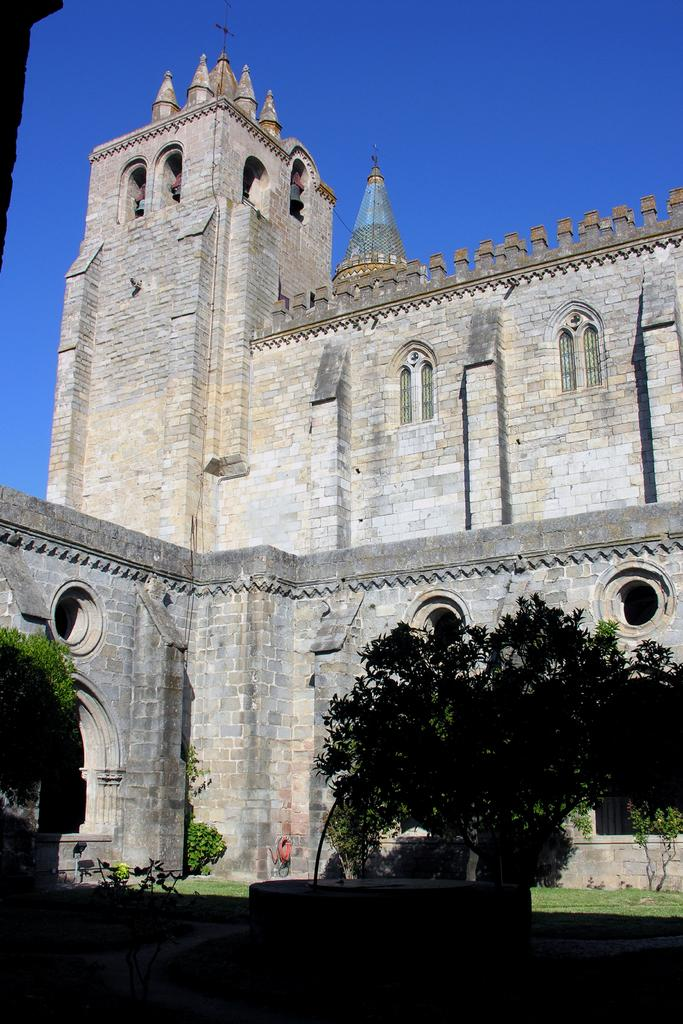What type of plant can be seen in the image? There is a tree in the image. What type of structure is present in the image? There is an old house in the image. What is visible in the background of the image? The background of the image is the sky. What type of station can be seen in the image? There is no station present in the image; it features a tree and an old house. What type of nerve is visible in the image? There is no nerve visible in the image; it features a tree and an old house. 